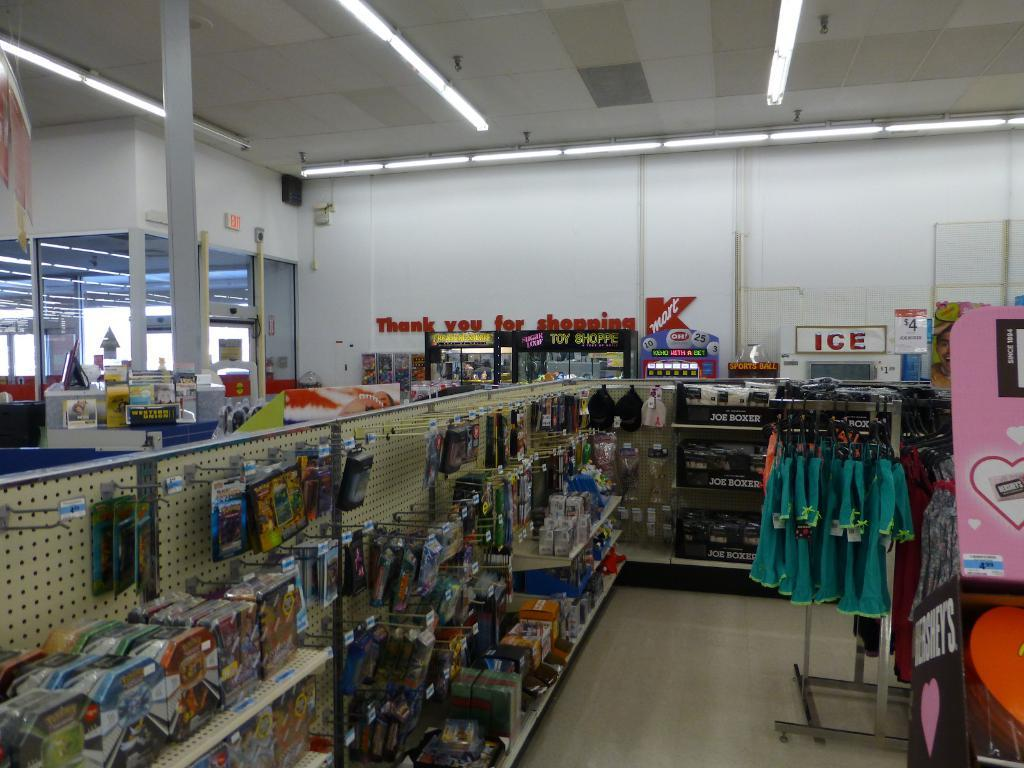<image>
Relay a brief, clear account of the picture shown. Kmart store with different supplies that has the message on the back wall: Thank you for shopping Kmart. 